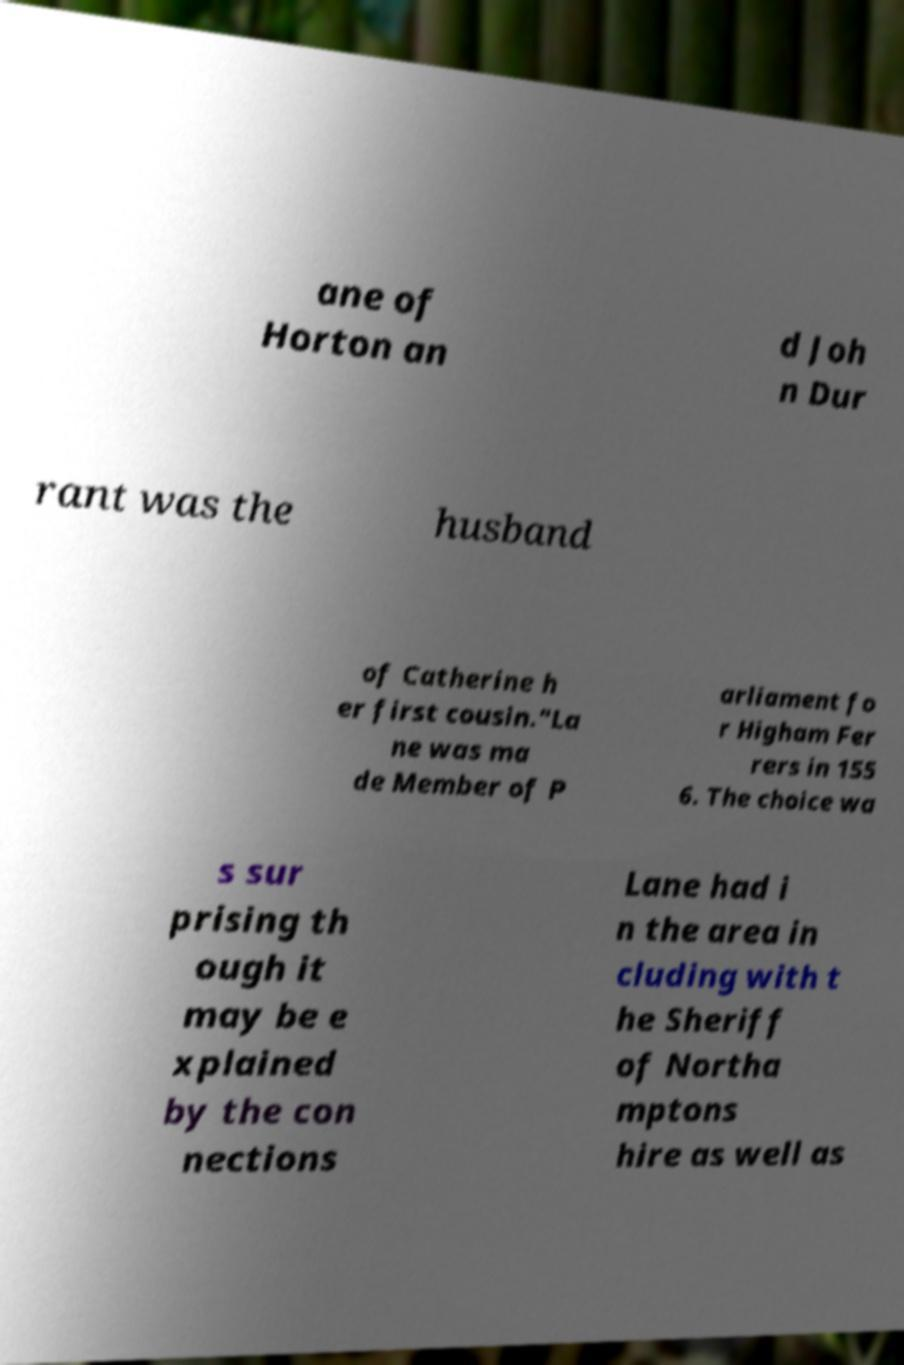There's text embedded in this image that I need extracted. Can you transcribe it verbatim? ane of Horton an d Joh n Dur rant was the husband of Catherine h er first cousin."La ne was ma de Member of P arliament fo r Higham Fer rers in 155 6. The choice wa s sur prising th ough it may be e xplained by the con nections Lane had i n the area in cluding with t he Sheriff of Northa mptons hire as well as 